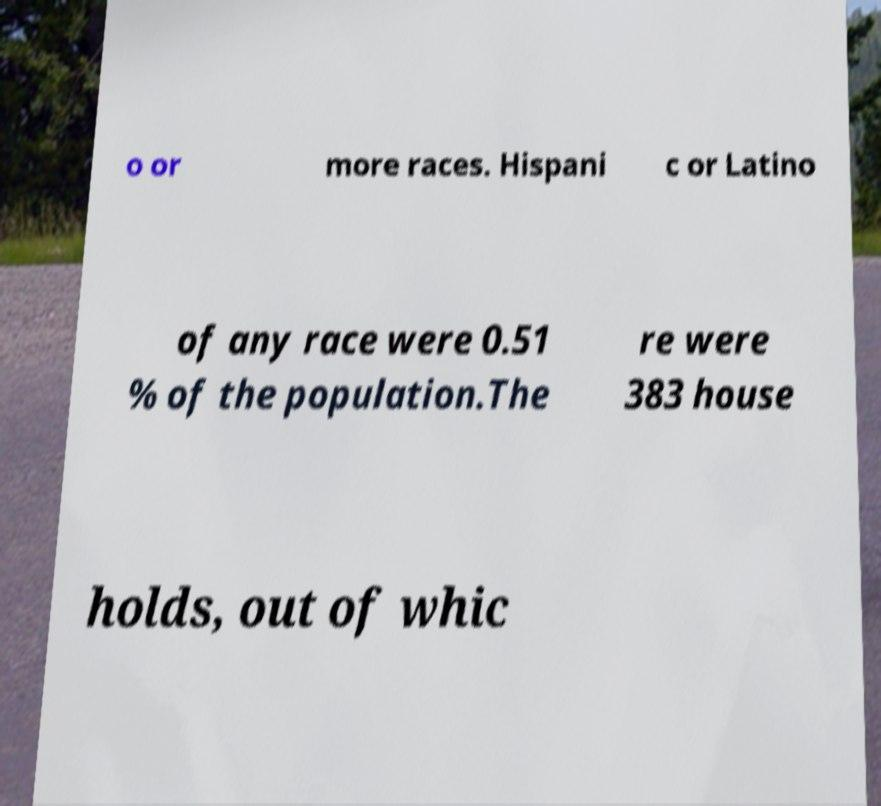There's text embedded in this image that I need extracted. Can you transcribe it verbatim? o or more races. Hispani c or Latino of any race were 0.51 % of the population.The re were 383 house holds, out of whic 